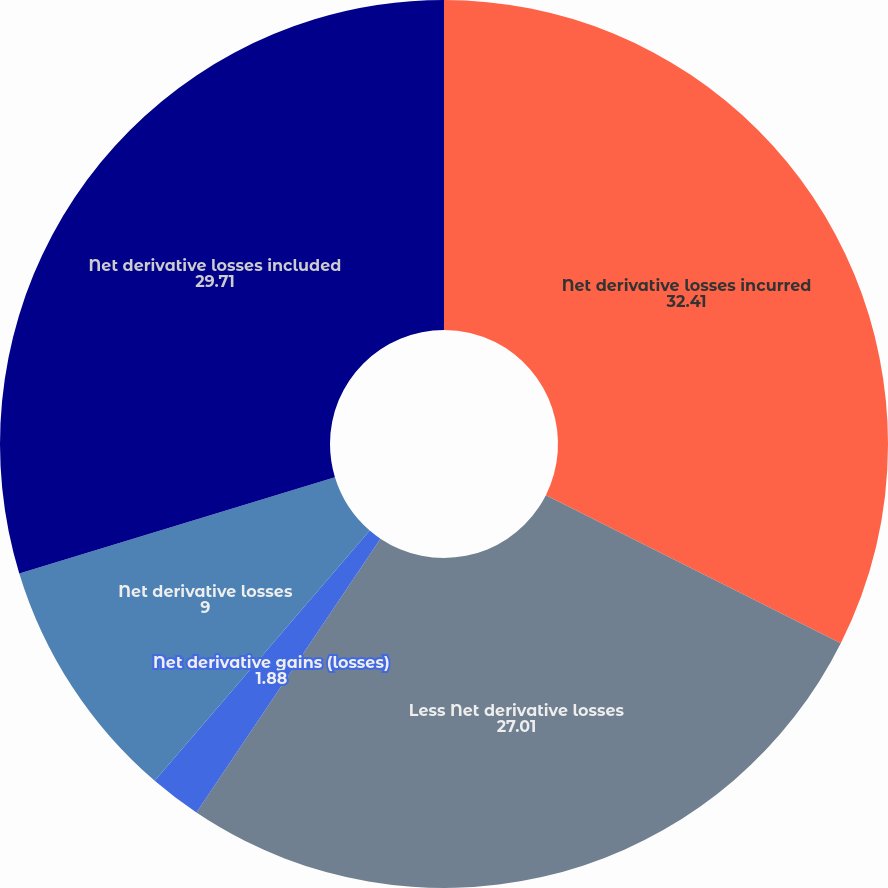Convert chart to OTSL. <chart><loc_0><loc_0><loc_500><loc_500><pie_chart><fcel>Net derivative losses incurred<fcel>Less Net derivative losses<fcel>Net derivative gains (losses)<fcel>Net derivative losses<fcel>Net derivative losses included<nl><fcel>32.41%<fcel>27.01%<fcel>1.88%<fcel>9.0%<fcel>29.71%<nl></chart> 